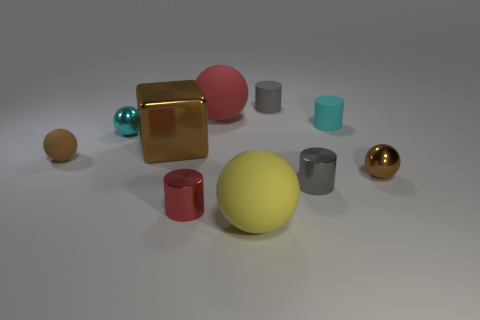Subtract all yellow spheres. How many spheres are left? 4 Subtract all brown metallic spheres. How many spheres are left? 4 Subtract all gray spheres. Subtract all cyan cylinders. How many spheres are left? 5 Subtract all cylinders. How many objects are left? 6 Subtract all small cyan matte objects. Subtract all brown metallic spheres. How many objects are left? 8 Add 2 small gray metallic cylinders. How many small gray metallic cylinders are left? 3 Add 6 tiny brown metallic things. How many tiny brown metallic things exist? 7 Subtract 0 green balls. How many objects are left? 10 